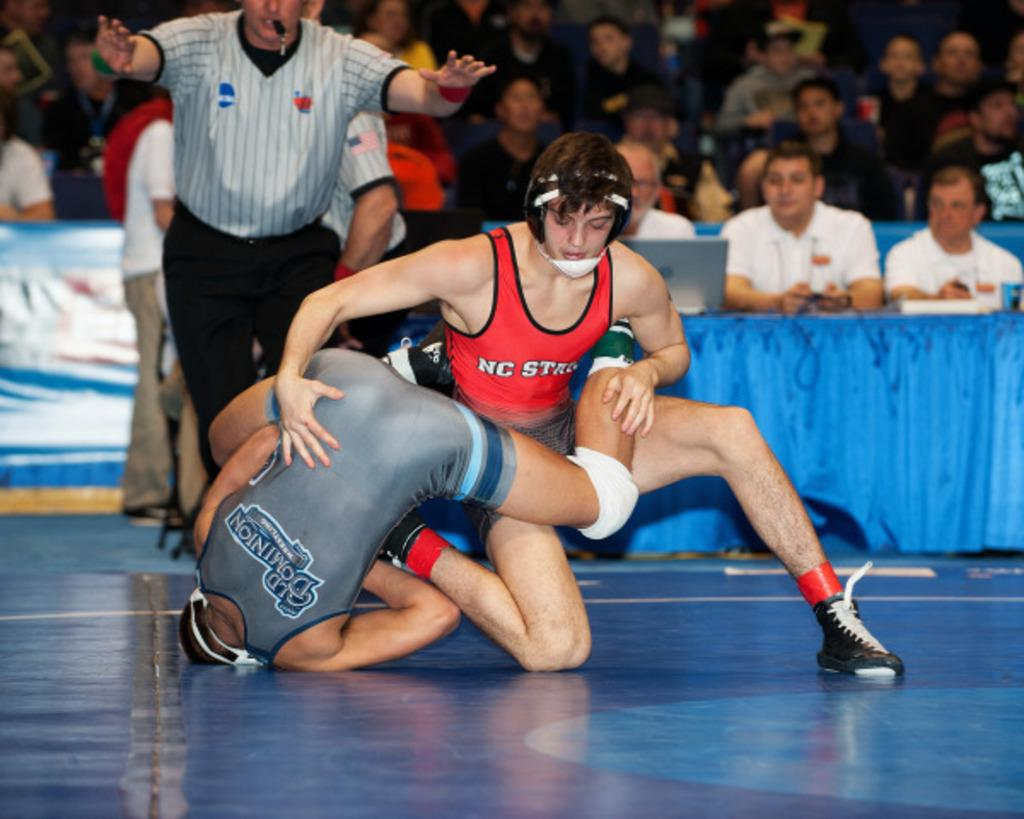<image>
Present a compact description of the photo's key features. A wrestler from NC state is winning a match. 